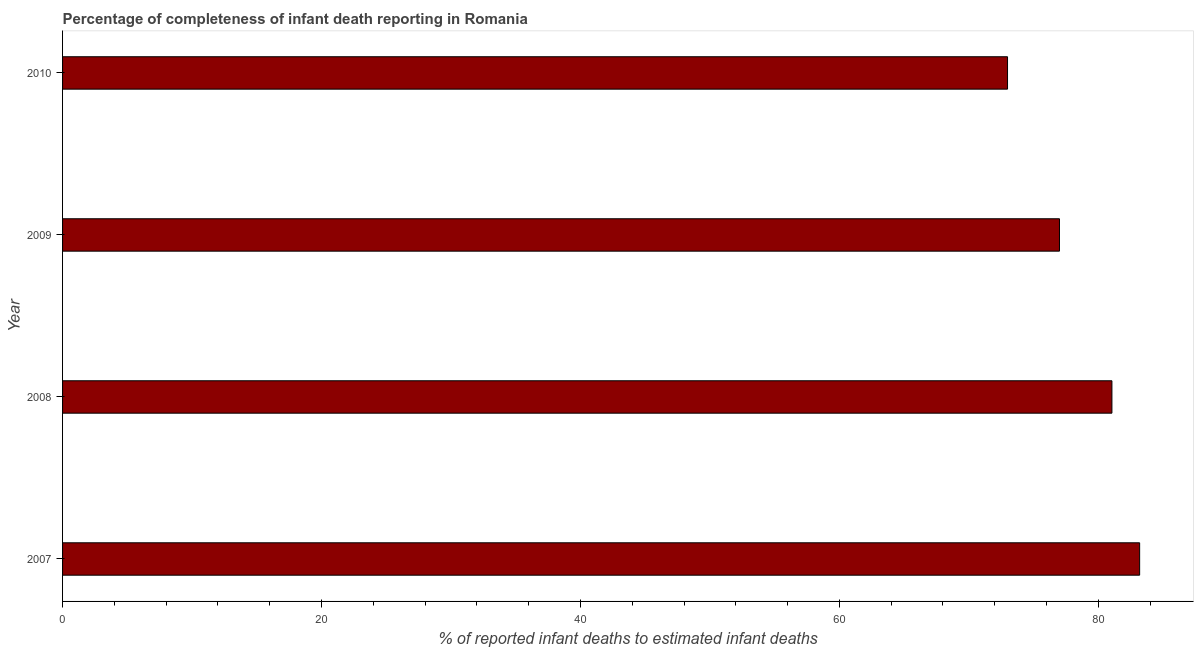Does the graph contain grids?
Offer a terse response. No. What is the title of the graph?
Make the answer very short. Percentage of completeness of infant death reporting in Romania. What is the label or title of the X-axis?
Your response must be concise. % of reported infant deaths to estimated infant deaths. What is the completeness of infant death reporting in 2007?
Give a very brief answer. 83.19. Across all years, what is the maximum completeness of infant death reporting?
Keep it short and to the point. 83.19. Across all years, what is the minimum completeness of infant death reporting?
Provide a succinct answer. 72.99. In which year was the completeness of infant death reporting minimum?
Provide a succinct answer. 2010. What is the sum of the completeness of infant death reporting?
Your answer should be very brief. 314.24. What is the difference between the completeness of infant death reporting in 2007 and 2008?
Ensure brevity in your answer.  2.14. What is the average completeness of infant death reporting per year?
Your answer should be compact. 78.56. What is the median completeness of infant death reporting?
Your answer should be compact. 79.03. In how many years, is the completeness of infant death reporting greater than 20 %?
Your response must be concise. 4. What is the ratio of the completeness of infant death reporting in 2007 to that in 2010?
Offer a terse response. 1.14. What is the difference between the highest and the second highest completeness of infant death reporting?
Your response must be concise. 2.14. Is the sum of the completeness of infant death reporting in 2007 and 2009 greater than the maximum completeness of infant death reporting across all years?
Your answer should be very brief. Yes. How many bars are there?
Offer a terse response. 4. Are all the bars in the graph horizontal?
Your answer should be compact. Yes. How many years are there in the graph?
Provide a succinct answer. 4. Are the values on the major ticks of X-axis written in scientific E-notation?
Offer a terse response. No. What is the % of reported infant deaths to estimated infant deaths of 2007?
Provide a short and direct response. 83.19. What is the % of reported infant deaths to estimated infant deaths of 2008?
Give a very brief answer. 81.05. What is the % of reported infant deaths to estimated infant deaths in 2009?
Provide a short and direct response. 77. What is the % of reported infant deaths to estimated infant deaths of 2010?
Make the answer very short. 72.99. What is the difference between the % of reported infant deaths to estimated infant deaths in 2007 and 2008?
Provide a short and direct response. 2.14. What is the difference between the % of reported infant deaths to estimated infant deaths in 2007 and 2009?
Your answer should be very brief. 6.19. What is the difference between the % of reported infant deaths to estimated infant deaths in 2007 and 2010?
Your response must be concise. 10.2. What is the difference between the % of reported infant deaths to estimated infant deaths in 2008 and 2009?
Offer a terse response. 4.05. What is the difference between the % of reported infant deaths to estimated infant deaths in 2008 and 2010?
Offer a terse response. 8.06. What is the difference between the % of reported infant deaths to estimated infant deaths in 2009 and 2010?
Offer a very short reply. 4.01. What is the ratio of the % of reported infant deaths to estimated infant deaths in 2007 to that in 2008?
Your response must be concise. 1.03. What is the ratio of the % of reported infant deaths to estimated infant deaths in 2007 to that in 2010?
Your response must be concise. 1.14. What is the ratio of the % of reported infant deaths to estimated infant deaths in 2008 to that in 2009?
Provide a short and direct response. 1.05. What is the ratio of the % of reported infant deaths to estimated infant deaths in 2008 to that in 2010?
Make the answer very short. 1.11. What is the ratio of the % of reported infant deaths to estimated infant deaths in 2009 to that in 2010?
Keep it short and to the point. 1.05. 